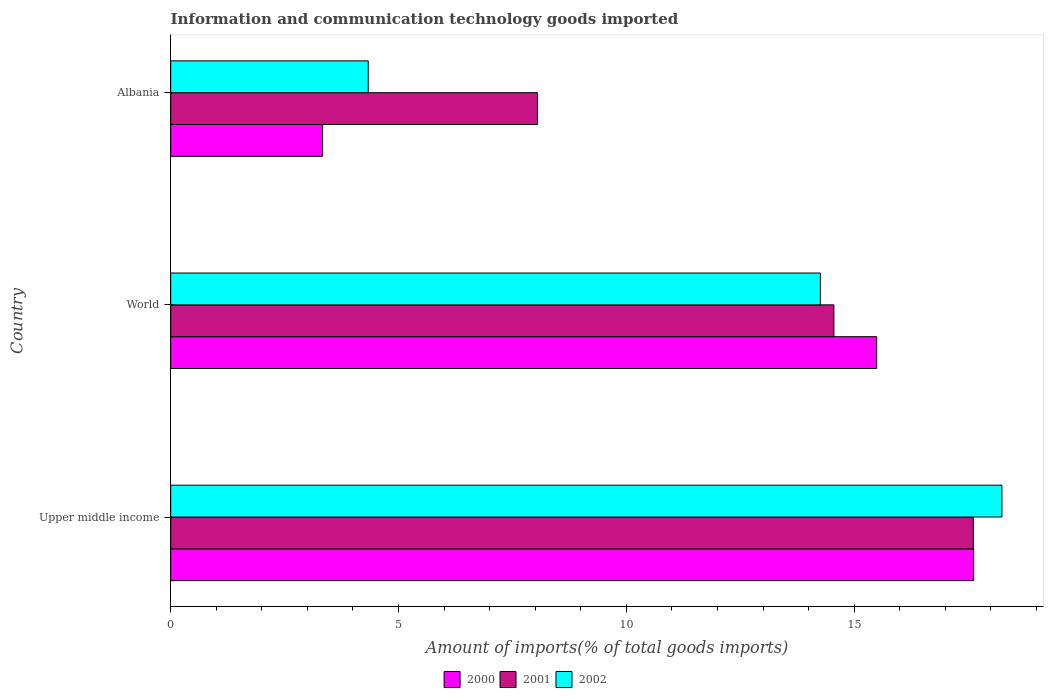Are the number of bars per tick equal to the number of legend labels?
Keep it short and to the point. Yes. How many bars are there on the 3rd tick from the bottom?
Your answer should be very brief. 3. What is the label of the 3rd group of bars from the top?
Make the answer very short. Upper middle income. In how many cases, is the number of bars for a given country not equal to the number of legend labels?
Provide a succinct answer. 0. What is the amount of goods imported in 2002 in World?
Ensure brevity in your answer.  14.26. Across all countries, what is the maximum amount of goods imported in 2000?
Your response must be concise. 17.62. Across all countries, what is the minimum amount of goods imported in 2001?
Provide a succinct answer. 8.05. In which country was the amount of goods imported in 2000 maximum?
Offer a terse response. Upper middle income. In which country was the amount of goods imported in 2000 minimum?
Give a very brief answer. Albania. What is the total amount of goods imported in 2001 in the graph?
Your answer should be very brief. 40.22. What is the difference between the amount of goods imported in 2001 in Albania and that in World?
Give a very brief answer. -6.51. What is the difference between the amount of goods imported in 2001 in Albania and the amount of goods imported in 2000 in Upper middle income?
Provide a succinct answer. -9.57. What is the average amount of goods imported in 2000 per country?
Your response must be concise. 12.15. What is the difference between the amount of goods imported in 2000 and amount of goods imported in 2001 in Upper middle income?
Your answer should be compact. 0.01. In how many countries, is the amount of goods imported in 2002 greater than 18 %?
Provide a short and direct response. 1. What is the ratio of the amount of goods imported in 2000 in Upper middle income to that in World?
Provide a succinct answer. 1.14. Is the amount of goods imported in 2002 in Albania less than that in World?
Ensure brevity in your answer.  Yes. What is the difference between the highest and the second highest amount of goods imported in 2001?
Provide a succinct answer. 3.06. What is the difference between the highest and the lowest amount of goods imported in 2000?
Ensure brevity in your answer.  14.29. Is it the case that in every country, the sum of the amount of goods imported in 2000 and amount of goods imported in 2001 is greater than the amount of goods imported in 2002?
Your response must be concise. Yes. How many bars are there?
Give a very brief answer. 9. How many countries are there in the graph?
Your response must be concise. 3. Are the values on the major ticks of X-axis written in scientific E-notation?
Your answer should be compact. No. Does the graph contain grids?
Your response must be concise. No. What is the title of the graph?
Ensure brevity in your answer.  Information and communication technology goods imported. Does "1978" appear as one of the legend labels in the graph?
Your answer should be very brief. No. What is the label or title of the X-axis?
Keep it short and to the point. Amount of imports(% of total goods imports). What is the Amount of imports(% of total goods imports) in 2000 in Upper middle income?
Your answer should be compact. 17.62. What is the Amount of imports(% of total goods imports) in 2001 in Upper middle income?
Provide a short and direct response. 17.61. What is the Amount of imports(% of total goods imports) of 2002 in Upper middle income?
Offer a very short reply. 18.24. What is the Amount of imports(% of total goods imports) in 2000 in World?
Your answer should be compact. 15.49. What is the Amount of imports(% of total goods imports) of 2001 in World?
Provide a short and direct response. 14.56. What is the Amount of imports(% of total goods imports) of 2002 in World?
Your answer should be compact. 14.26. What is the Amount of imports(% of total goods imports) in 2000 in Albania?
Provide a short and direct response. 3.33. What is the Amount of imports(% of total goods imports) of 2001 in Albania?
Offer a terse response. 8.05. What is the Amount of imports(% of total goods imports) in 2002 in Albania?
Make the answer very short. 4.34. Across all countries, what is the maximum Amount of imports(% of total goods imports) of 2000?
Your response must be concise. 17.62. Across all countries, what is the maximum Amount of imports(% of total goods imports) of 2001?
Offer a very short reply. 17.61. Across all countries, what is the maximum Amount of imports(% of total goods imports) of 2002?
Ensure brevity in your answer.  18.24. Across all countries, what is the minimum Amount of imports(% of total goods imports) in 2000?
Your answer should be compact. 3.33. Across all countries, what is the minimum Amount of imports(% of total goods imports) of 2001?
Your answer should be compact. 8.05. Across all countries, what is the minimum Amount of imports(% of total goods imports) in 2002?
Offer a terse response. 4.34. What is the total Amount of imports(% of total goods imports) in 2000 in the graph?
Your answer should be compact. 36.45. What is the total Amount of imports(% of total goods imports) of 2001 in the graph?
Your answer should be very brief. 40.22. What is the total Amount of imports(% of total goods imports) of 2002 in the graph?
Your answer should be very brief. 36.84. What is the difference between the Amount of imports(% of total goods imports) of 2000 in Upper middle income and that in World?
Your answer should be very brief. 2.13. What is the difference between the Amount of imports(% of total goods imports) in 2001 in Upper middle income and that in World?
Offer a terse response. 3.06. What is the difference between the Amount of imports(% of total goods imports) of 2002 in Upper middle income and that in World?
Your answer should be compact. 3.98. What is the difference between the Amount of imports(% of total goods imports) of 2000 in Upper middle income and that in Albania?
Give a very brief answer. 14.29. What is the difference between the Amount of imports(% of total goods imports) of 2001 in Upper middle income and that in Albania?
Ensure brevity in your answer.  9.57. What is the difference between the Amount of imports(% of total goods imports) in 2002 in Upper middle income and that in Albania?
Ensure brevity in your answer.  13.91. What is the difference between the Amount of imports(% of total goods imports) in 2000 in World and that in Albania?
Offer a very short reply. 12.16. What is the difference between the Amount of imports(% of total goods imports) in 2001 in World and that in Albania?
Make the answer very short. 6.51. What is the difference between the Amount of imports(% of total goods imports) of 2002 in World and that in Albania?
Give a very brief answer. 9.92. What is the difference between the Amount of imports(% of total goods imports) in 2000 in Upper middle income and the Amount of imports(% of total goods imports) in 2001 in World?
Your answer should be compact. 3.07. What is the difference between the Amount of imports(% of total goods imports) in 2000 in Upper middle income and the Amount of imports(% of total goods imports) in 2002 in World?
Provide a short and direct response. 3.36. What is the difference between the Amount of imports(% of total goods imports) in 2001 in Upper middle income and the Amount of imports(% of total goods imports) in 2002 in World?
Provide a succinct answer. 3.36. What is the difference between the Amount of imports(% of total goods imports) of 2000 in Upper middle income and the Amount of imports(% of total goods imports) of 2001 in Albania?
Your answer should be very brief. 9.57. What is the difference between the Amount of imports(% of total goods imports) in 2000 in Upper middle income and the Amount of imports(% of total goods imports) in 2002 in Albania?
Your answer should be very brief. 13.29. What is the difference between the Amount of imports(% of total goods imports) of 2001 in Upper middle income and the Amount of imports(% of total goods imports) of 2002 in Albania?
Your response must be concise. 13.28. What is the difference between the Amount of imports(% of total goods imports) of 2000 in World and the Amount of imports(% of total goods imports) of 2001 in Albania?
Offer a very short reply. 7.44. What is the difference between the Amount of imports(% of total goods imports) of 2000 in World and the Amount of imports(% of total goods imports) of 2002 in Albania?
Your answer should be very brief. 11.16. What is the difference between the Amount of imports(% of total goods imports) in 2001 in World and the Amount of imports(% of total goods imports) in 2002 in Albania?
Your answer should be compact. 10.22. What is the average Amount of imports(% of total goods imports) of 2000 per country?
Your answer should be very brief. 12.15. What is the average Amount of imports(% of total goods imports) of 2001 per country?
Make the answer very short. 13.41. What is the average Amount of imports(% of total goods imports) in 2002 per country?
Ensure brevity in your answer.  12.28. What is the difference between the Amount of imports(% of total goods imports) of 2000 and Amount of imports(% of total goods imports) of 2001 in Upper middle income?
Provide a short and direct response. 0.01. What is the difference between the Amount of imports(% of total goods imports) of 2000 and Amount of imports(% of total goods imports) of 2002 in Upper middle income?
Your answer should be very brief. -0.62. What is the difference between the Amount of imports(% of total goods imports) in 2001 and Amount of imports(% of total goods imports) in 2002 in Upper middle income?
Ensure brevity in your answer.  -0.63. What is the difference between the Amount of imports(% of total goods imports) of 2000 and Amount of imports(% of total goods imports) of 2001 in World?
Offer a terse response. 0.94. What is the difference between the Amount of imports(% of total goods imports) of 2000 and Amount of imports(% of total goods imports) of 2002 in World?
Offer a very short reply. 1.24. What is the difference between the Amount of imports(% of total goods imports) of 2001 and Amount of imports(% of total goods imports) of 2002 in World?
Provide a succinct answer. 0.3. What is the difference between the Amount of imports(% of total goods imports) in 2000 and Amount of imports(% of total goods imports) in 2001 in Albania?
Provide a short and direct response. -4.72. What is the difference between the Amount of imports(% of total goods imports) of 2000 and Amount of imports(% of total goods imports) of 2002 in Albania?
Offer a terse response. -1. What is the difference between the Amount of imports(% of total goods imports) in 2001 and Amount of imports(% of total goods imports) in 2002 in Albania?
Offer a very short reply. 3.71. What is the ratio of the Amount of imports(% of total goods imports) of 2000 in Upper middle income to that in World?
Keep it short and to the point. 1.14. What is the ratio of the Amount of imports(% of total goods imports) of 2001 in Upper middle income to that in World?
Make the answer very short. 1.21. What is the ratio of the Amount of imports(% of total goods imports) in 2002 in Upper middle income to that in World?
Give a very brief answer. 1.28. What is the ratio of the Amount of imports(% of total goods imports) in 2000 in Upper middle income to that in Albania?
Ensure brevity in your answer.  5.29. What is the ratio of the Amount of imports(% of total goods imports) of 2001 in Upper middle income to that in Albania?
Provide a succinct answer. 2.19. What is the ratio of the Amount of imports(% of total goods imports) of 2002 in Upper middle income to that in Albania?
Make the answer very short. 4.21. What is the ratio of the Amount of imports(% of total goods imports) of 2000 in World to that in Albania?
Your answer should be compact. 4.65. What is the ratio of the Amount of imports(% of total goods imports) in 2001 in World to that in Albania?
Provide a short and direct response. 1.81. What is the ratio of the Amount of imports(% of total goods imports) of 2002 in World to that in Albania?
Offer a terse response. 3.29. What is the difference between the highest and the second highest Amount of imports(% of total goods imports) in 2000?
Give a very brief answer. 2.13. What is the difference between the highest and the second highest Amount of imports(% of total goods imports) of 2001?
Your answer should be very brief. 3.06. What is the difference between the highest and the second highest Amount of imports(% of total goods imports) in 2002?
Make the answer very short. 3.98. What is the difference between the highest and the lowest Amount of imports(% of total goods imports) of 2000?
Your response must be concise. 14.29. What is the difference between the highest and the lowest Amount of imports(% of total goods imports) in 2001?
Offer a terse response. 9.57. What is the difference between the highest and the lowest Amount of imports(% of total goods imports) of 2002?
Make the answer very short. 13.91. 